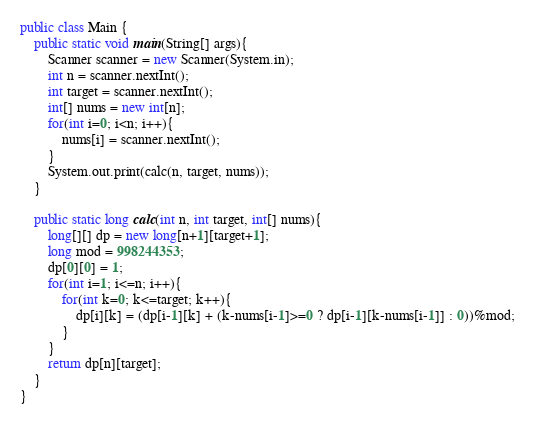Convert code to text. <code><loc_0><loc_0><loc_500><loc_500><_Java_>public class Main {
    public static void main(String[] args){
        Scanner scanner = new Scanner(System.in);
        int n = scanner.nextInt();
        int target = scanner.nextInt();
        int[] nums = new int[n];
        for(int i=0; i<n; i++){
            nums[i] = scanner.nextInt();
        }
        System.out.print(calc(n, target, nums));
    }

    public static long calc(int n, int target, int[] nums){
        long[][] dp = new long[n+1][target+1];
        long mod = 998244353;
        dp[0][0] = 1;
        for(int i=1; i<=n; i++){
            for(int k=0; k<=target; k++){
                dp[i][k] = (dp[i-1][k] + (k-nums[i-1]>=0 ? dp[i-1][k-nums[i-1]] : 0))%mod;
            }
        }
        return dp[n][target];
    }
}</code> 